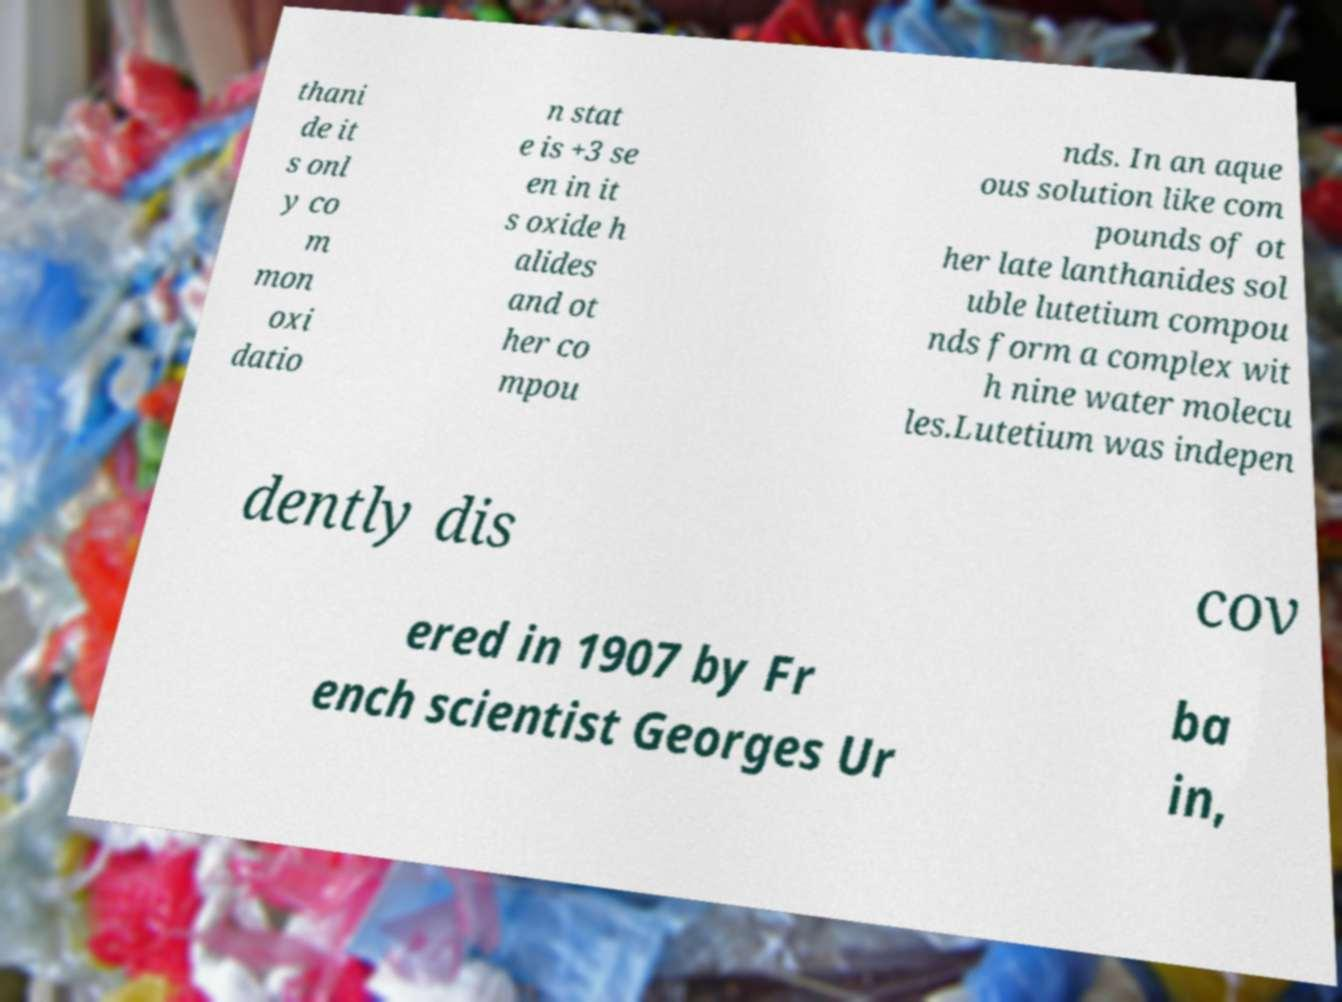For documentation purposes, I need the text within this image transcribed. Could you provide that? thani de it s onl y co m mon oxi datio n stat e is +3 se en in it s oxide h alides and ot her co mpou nds. In an aque ous solution like com pounds of ot her late lanthanides sol uble lutetium compou nds form a complex wit h nine water molecu les.Lutetium was indepen dently dis cov ered in 1907 by Fr ench scientist Georges Ur ba in, 